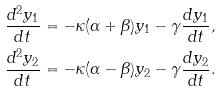<formula> <loc_0><loc_0><loc_500><loc_500>\frac { d ^ { 2 } y _ { 1 } } { d t } & = - \kappa ( \alpha + \beta ) y _ { 1 } - \gamma \frac { d y _ { 1 } } { d t } , \\ \frac { d ^ { 2 } y _ { 2 } } { d t } & = - \kappa ( \alpha - \beta ) y _ { 2 } - \gamma \frac { d y _ { 2 } } { d t } .</formula> 